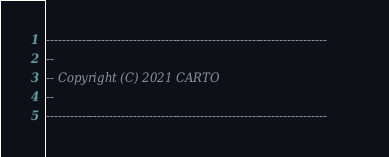Convert code to text. <code><loc_0><loc_0><loc_500><loc_500><_SQL_>-----------------------------------------------------------------------
--
-- Copyright (C) 2021 CARTO
--
-----------------------------------------------------------------------
</code> 